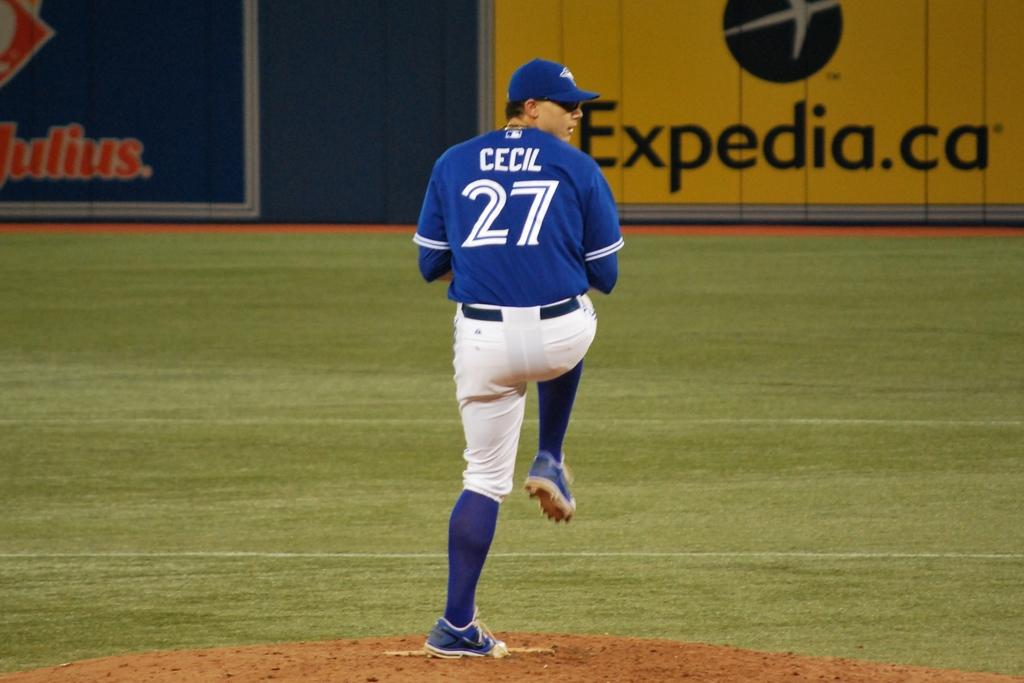Provide a one-sentence caption for the provided image. a baseball pitcher number 27 on the mound ready to throw. 